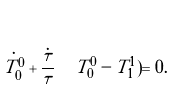Convert formula to latex. <formula><loc_0><loc_0><loc_500><loc_500>\dot { T _ { 0 } ^ { 0 } } + \frac { \dot { \tau } } { \tau } \Big ( T _ { 0 } ^ { 0 } - T _ { 1 } ^ { 1 } ) = 0 .</formula> 